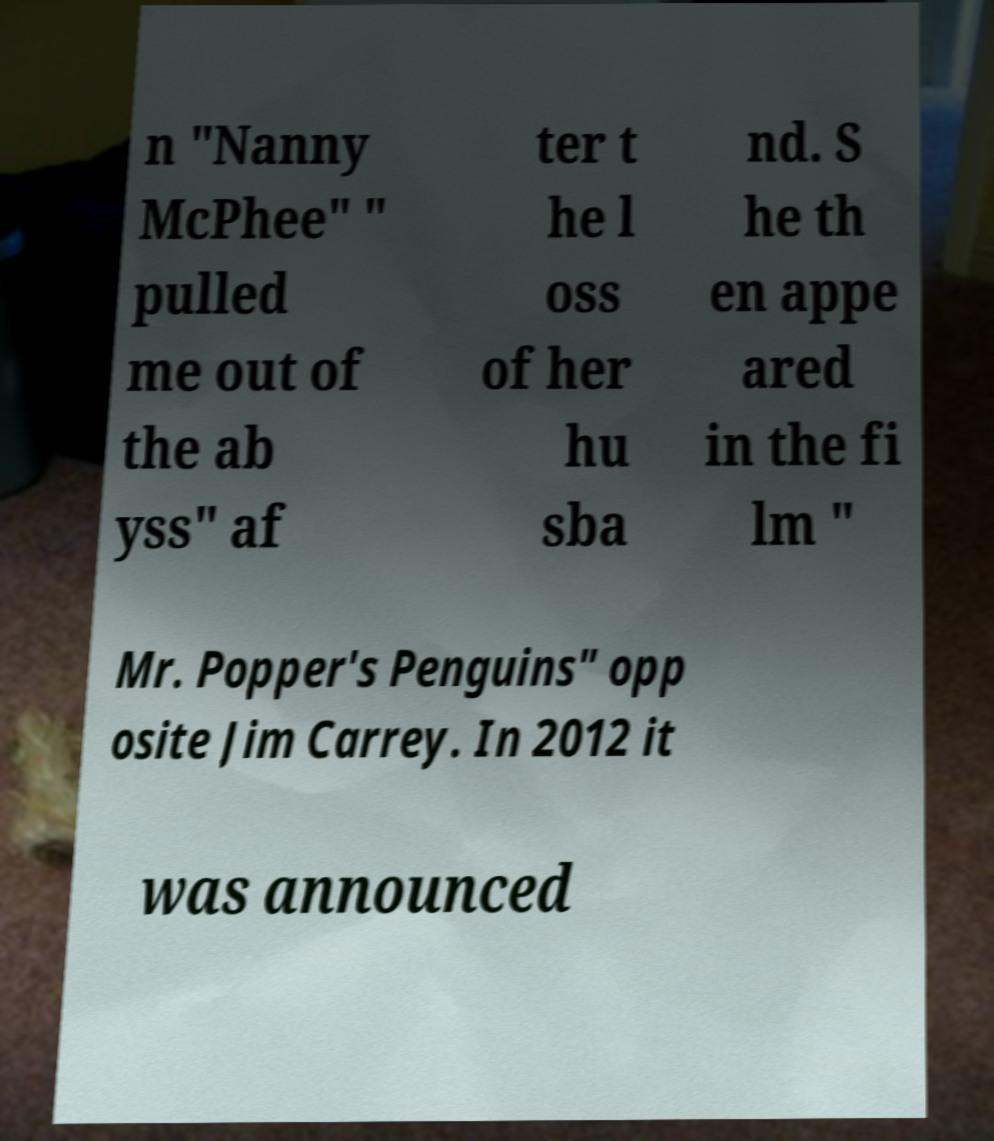What messages or text are displayed in this image? I need them in a readable, typed format. n "Nanny McPhee" " pulled me out of the ab yss" af ter t he l oss of her hu sba nd. S he th en appe ared in the fi lm " Mr. Popper's Penguins" opp osite Jim Carrey. In 2012 it was announced 